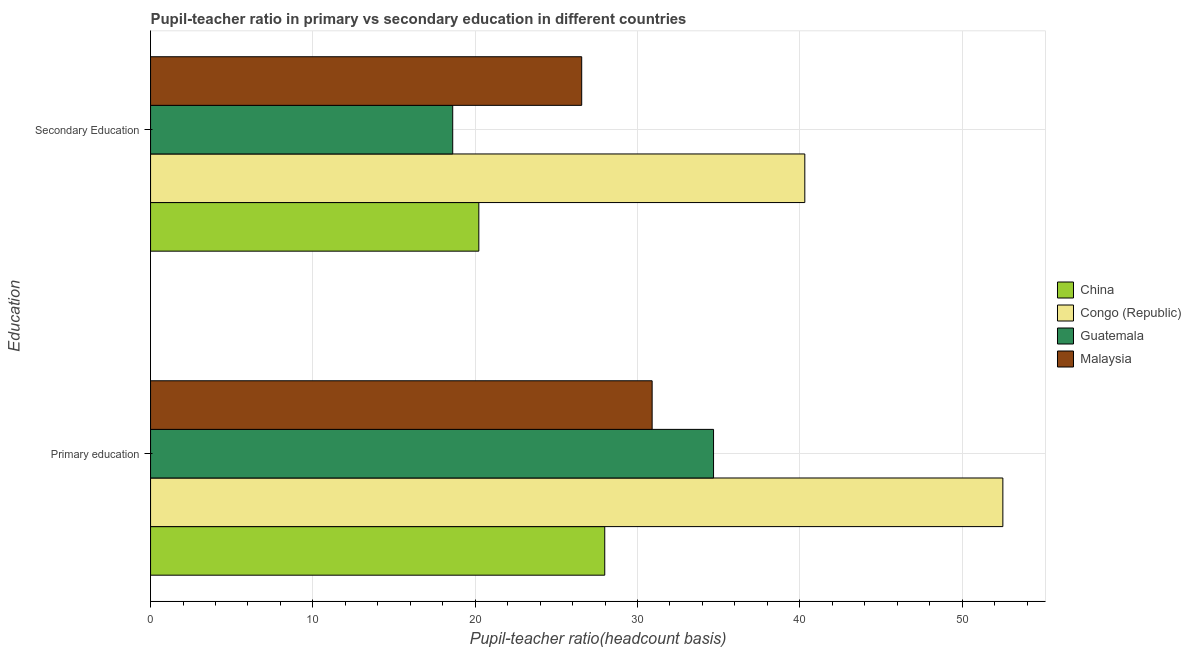How many different coloured bars are there?
Provide a short and direct response. 4. How many groups of bars are there?
Offer a terse response. 2. Are the number of bars on each tick of the Y-axis equal?
Provide a short and direct response. Yes. How many bars are there on the 1st tick from the top?
Your answer should be very brief. 4. How many bars are there on the 1st tick from the bottom?
Ensure brevity in your answer.  4. What is the label of the 1st group of bars from the top?
Your answer should be compact. Secondary Education. What is the pupil-teacher ratio in primary education in Malaysia?
Your response must be concise. 30.9. Across all countries, what is the maximum pupil-teacher ratio in primary education?
Give a very brief answer. 52.51. Across all countries, what is the minimum pupil-teacher ratio in primary education?
Provide a succinct answer. 27.98. In which country was the pupil-teacher ratio in primary education maximum?
Offer a terse response. Congo (Republic). In which country was the pupil teacher ratio on secondary education minimum?
Give a very brief answer. Guatemala. What is the total pupil teacher ratio on secondary education in the graph?
Your answer should be very brief. 105.71. What is the difference between the pupil teacher ratio on secondary education in Guatemala and that in Congo (Republic)?
Give a very brief answer. -21.69. What is the difference between the pupil-teacher ratio in primary education in Malaysia and the pupil teacher ratio on secondary education in China?
Your answer should be compact. 10.68. What is the average pupil-teacher ratio in primary education per country?
Offer a very short reply. 36.52. What is the difference between the pupil-teacher ratio in primary education and pupil teacher ratio on secondary education in Congo (Republic)?
Offer a terse response. 12.2. In how many countries, is the pupil-teacher ratio in primary education greater than 36 ?
Your response must be concise. 1. What is the ratio of the pupil-teacher ratio in primary education in Congo (Republic) to that in China?
Your answer should be very brief. 1.88. Is the pupil teacher ratio on secondary education in China less than that in Malaysia?
Provide a short and direct response. Yes. In how many countries, is the pupil teacher ratio on secondary education greater than the average pupil teacher ratio on secondary education taken over all countries?
Ensure brevity in your answer.  2. What does the 4th bar from the top in Secondary Education represents?
Make the answer very short. China. What does the 4th bar from the bottom in Secondary Education represents?
Keep it short and to the point. Malaysia. How many bars are there?
Make the answer very short. 8. Are all the bars in the graph horizontal?
Your response must be concise. Yes. Are the values on the major ticks of X-axis written in scientific E-notation?
Offer a very short reply. No. Does the graph contain grids?
Provide a succinct answer. Yes. Where does the legend appear in the graph?
Provide a short and direct response. Center right. What is the title of the graph?
Provide a short and direct response. Pupil-teacher ratio in primary vs secondary education in different countries. Does "Cambodia" appear as one of the legend labels in the graph?
Offer a very short reply. No. What is the label or title of the X-axis?
Give a very brief answer. Pupil-teacher ratio(headcount basis). What is the label or title of the Y-axis?
Your response must be concise. Education. What is the Pupil-teacher ratio(headcount basis) in China in Primary education?
Offer a terse response. 27.98. What is the Pupil-teacher ratio(headcount basis) in Congo (Republic) in Primary education?
Offer a very short reply. 52.51. What is the Pupil-teacher ratio(headcount basis) in Guatemala in Primary education?
Keep it short and to the point. 34.69. What is the Pupil-teacher ratio(headcount basis) of Malaysia in Primary education?
Offer a very short reply. 30.9. What is the Pupil-teacher ratio(headcount basis) in China in Secondary Education?
Keep it short and to the point. 20.23. What is the Pupil-teacher ratio(headcount basis) of Congo (Republic) in Secondary Education?
Your response must be concise. 40.31. What is the Pupil-teacher ratio(headcount basis) of Guatemala in Secondary Education?
Ensure brevity in your answer.  18.62. What is the Pupil-teacher ratio(headcount basis) of Malaysia in Secondary Education?
Provide a succinct answer. 26.56. Across all Education, what is the maximum Pupil-teacher ratio(headcount basis) in China?
Offer a very short reply. 27.98. Across all Education, what is the maximum Pupil-teacher ratio(headcount basis) in Congo (Republic)?
Offer a very short reply. 52.51. Across all Education, what is the maximum Pupil-teacher ratio(headcount basis) in Guatemala?
Provide a succinct answer. 34.69. Across all Education, what is the maximum Pupil-teacher ratio(headcount basis) of Malaysia?
Give a very brief answer. 30.9. Across all Education, what is the minimum Pupil-teacher ratio(headcount basis) of China?
Your response must be concise. 20.23. Across all Education, what is the minimum Pupil-teacher ratio(headcount basis) in Congo (Republic)?
Offer a very short reply. 40.31. Across all Education, what is the minimum Pupil-teacher ratio(headcount basis) of Guatemala?
Offer a terse response. 18.62. Across all Education, what is the minimum Pupil-teacher ratio(headcount basis) of Malaysia?
Ensure brevity in your answer.  26.56. What is the total Pupil-teacher ratio(headcount basis) in China in the graph?
Provide a short and direct response. 48.21. What is the total Pupil-teacher ratio(headcount basis) in Congo (Republic) in the graph?
Make the answer very short. 92.82. What is the total Pupil-teacher ratio(headcount basis) of Guatemala in the graph?
Your response must be concise. 53.3. What is the total Pupil-teacher ratio(headcount basis) in Malaysia in the graph?
Your answer should be very brief. 57.47. What is the difference between the Pupil-teacher ratio(headcount basis) in China in Primary education and that in Secondary Education?
Offer a very short reply. 7.76. What is the difference between the Pupil-teacher ratio(headcount basis) in Congo (Republic) in Primary education and that in Secondary Education?
Provide a short and direct response. 12.2. What is the difference between the Pupil-teacher ratio(headcount basis) in Guatemala in Primary education and that in Secondary Education?
Keep it short and to the point. 16.07. What is the difference between the Pupil-teacher ratio(headcount basis) in Malaysia in Primary education and that in Secondary Education?
Your response must be concise. 4.34. What is the difference between the Pupil-teacher ratio(headcount basis) in China in Primary education and the Pupil-teacher ratio(headcount basis) in Congo (Republic) in Secondary Education?
Provide a short and direct response. -12.33. What is the difference between the Pupil-teacher ratio(headcount basis) in China in Primary education and the Pupil-teacher ratio(headcount basis) in Guatemala in Secondary Education?
Provide a succinct answer. 9.37. What is the difference between the Pupil-teacher ratio(headcount basis) of China in Primary education and the Pupil-teacher ratio(headcount basis) of Malaysia in Secondary Education?
Your answer should be compact. 1.42. What is the difference between the Pupil-teacher ratio(headcount basis) of Congo (Republic) in Primary education and the Pupil-teacher ratio(headcount basis) of Guatemala in Secondary Education?
Provide a short and direct response. 33.9. What is the difference between the Pupil-teacher ratio(headcount basis) in Congo (Republic) in Primary education and the Pupil-teacher ratio(headcount basis) in Malaysia in Secondary Education?
Your answer should be very brief. 25.95. What is the difference between the Pupil-teacher ratio(headcount basis) in Guatemala in Primary education and the Pupil-teacher ratio(headcount basis) in Malaysia in Secondary Education?
Your answer should be very brief. 8.12. What is the average Pupil-teacher ratio(headcount basis) of China per Education?
Your answer should be compact. 24.1. What is the average Pupil-teacher ratio(headcount basis) in Congo (Republic) per Education?
Provide a succinct answer. 46.41. What is the average Pupil-teacher ratio(headcount basis) of Guatemala per Education?
Provide a short and direct response. 26.65. What is the average Pupil-teacher ratio(headcount basis) of Malaysia per Education?
Offer a very short reply. 28.73. What is the difference between the Pupil-teacher ratio(headcount basis) in China and Pupil-teacher ratio(headcount basis) in Congo (Republic) in Primary education?
Provide a short and direct response. -24.53. What is the difference between the Pupil-teacher ratio(headcount basis) in China and Pupil-teacher ratio(headcount basis) in Guatemala in Primary education?
Give a very brief answer. -6.7. What is the difference between the Pupil-teacher ratio(headcount basis) in China and Pupil-teacher ratio(headcount basis) in Malaysia in Primary education?
Your response must be concise. -2.92. What is the difference between the Pupil-teacher ratio(headcount basis) in Congo (Republic) and Pupil-teacher ratio(headcount basis) in Guatemala in Primary education?
Keep it short and to the point. 17.83. What is the difference between the Pupil-teacher ratio(headcount basis) of Congo (Republic) and Pupil-teacher ratio(headcount basis) of Malaysia in Primary education?
Ensure brevity in your answer.  21.61. What is the difference between the Pupil-teacher ratio(headcount basis) of Guatemala and Pupil-teacher ratio(headcount basis) of Malaysia in Primary education?
Provide a succinct answer. 3.78. What is the difference between the Pupil-teacher ratio(headcount basis) in China and Pupil-teacher ratio(headcount basis) in Congo (Republic) in Secondary Education?
Your answer should be compact. -20.08. What is the difference between the Pupil-teacher ratio(headcount basis) in China and Pupil-teacher ratio(headcount basis) in Guatemala in Secondary Education?
Your answer should be very brief. 1.61. What is the difference between the Pupil-teacher ratio(headcount basis) of China and Pupil-teacher ratio(headcount basis) of Malaysia in Secondary Education?
Offer a very short reply. -6.34. What is the difference between the Pupil-teacher ratio(headcount basis) of Congo (Republic) and Pupil-teacher ratio(headcount basis) of Guatemala in Secondary Education?
Ensure brevity in your answer.  21.69. What is the difference between the Pupil-teacher ratio(headcount basis) in Congo (Republic) and Pupil-teacher ratio(headcount basis) in Malaysia in Secondary Education?
Keep it short and to the point. 13.75. What is the difference between the Pupil-teacher ratio(headcount basis) in Guatemala and Pupil-teacher ratio(headcount basis) in Malaysia in Secondary Education?
Ensure brevity in your answer.  -7.95. What is the ratio of the Pupil-teacher ratio(headcount basis) of China in Primary education to that in Secondary Education?
Offer a very short reply. 1.38. What is the ratio of the Pupil-teacher ratio(headcount basis) in Congo (Republic) in Primary education to that in Secondary Education?
Make the answer very short. 1.3. What is the ratio of the Pupil-teacher ratio(headcount basis) of Guatemala in Primary education to that in Secondary Education?
Give a very brief answer. 1.86. What is the ratio of the Pupil-teacher ratio(headcount basis) in Malaysia in Primary education to that in Secondary Education?
Offer a very short reply. 1.16. What is the difference between the highest and the second highest Pupil-teacher ratio(headcount basis) in China?
Your response must be concise. 7.76. What is the difference between the highest and the second highest Pupil-teacher ratio(headcount basis) of Congo (Republic)?
Your response must be concise. 12.2. What is the difference between the highest and the second highest Pupil-teacher ratio(headcount basis) in Guatemala?
Make the answer very short. 16.07. What is the difference between the highest and the second highest Pupil-teacher ratio(headcount basis) of Malaysia?
Offer a terse response. 4.34. What is the difference between the highest and the lowest Pupil-teacher ratio(headcount basis) in China?
Give a very brief answer. 7.76. What is the difference between the highest and the lowest Pupil-teacher ratio(headcount basis) in Congo (Republic)?
Make the answer very short. 12.2. What is the difference between the highest and the lowest Pupil-teacher ratio(headcount basis) of Guatemala?
Keep it short and to the point. 16.07. What is the difference between the highest and the lowest Pupil-teacher ratio(headcount basis) in Malaysia?
Your response must be concise. 4.34. 